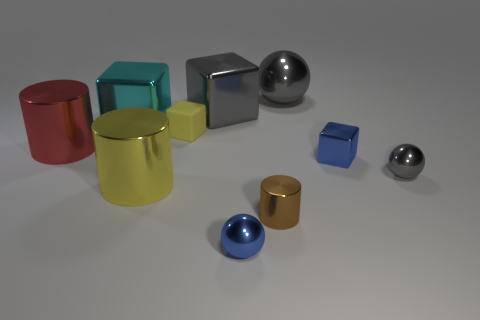There is a cylinder behind the big object in front of the small blue metallic cube; what is its size?
Make the answer very short. Large. There is a blue object that is the same shape as the cyan metallic object; what is it made of?
Provide a short and direct response. Metal. How many other red shiny cylinders have the same size as the red cylinder?
Provide a short and direct response. 0. Does the cyan shiny thing have the same size as the gray metal block?
Make the answer very short. Yes. There is a metal thing that is both in front of the tiny metal block and to the left of the yellow rubber thing; what size is it?
Provide a succinct answer. Large. Are there more small things to the right of the brown shiny cylinder than big cubes that are in front of the small gray ball?
Your answer should be very brief. Yes. The other big object that is the same shape as the large cyan object is what color?
Keep it short and to the point. Gray. There is a large metallic cylinder that is right of the big red object; is it the same color as the tiny rubber object?
Ensure brevity in your answer.  Yes. How many gray metal cubes are there?
Offer a very short reply. 1. Do the cylinder to the right of the tiny blue metallic ball and the yellow block have the same material?
Ensure brevity in your answer.  No. 